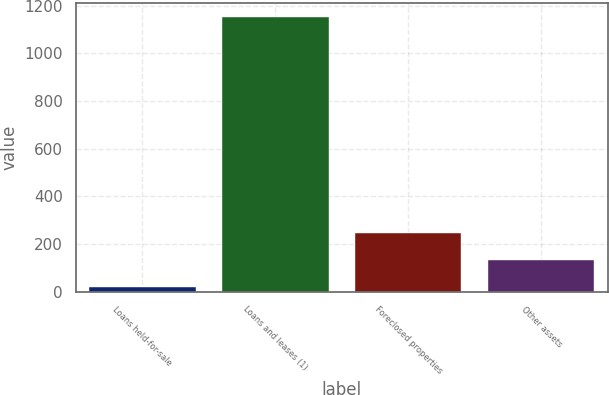<chart> <loc_0><loc_0><loc_500><loc_500><bar_chart><fcel>Loans held-for-sale<fcel>Loans and leases (1)<fcel>Foreclosed properties<fcel>Other assets<nl><fcel>19<fcel>1152<fcel>245.6<fcel>132.3<nl></chart> 